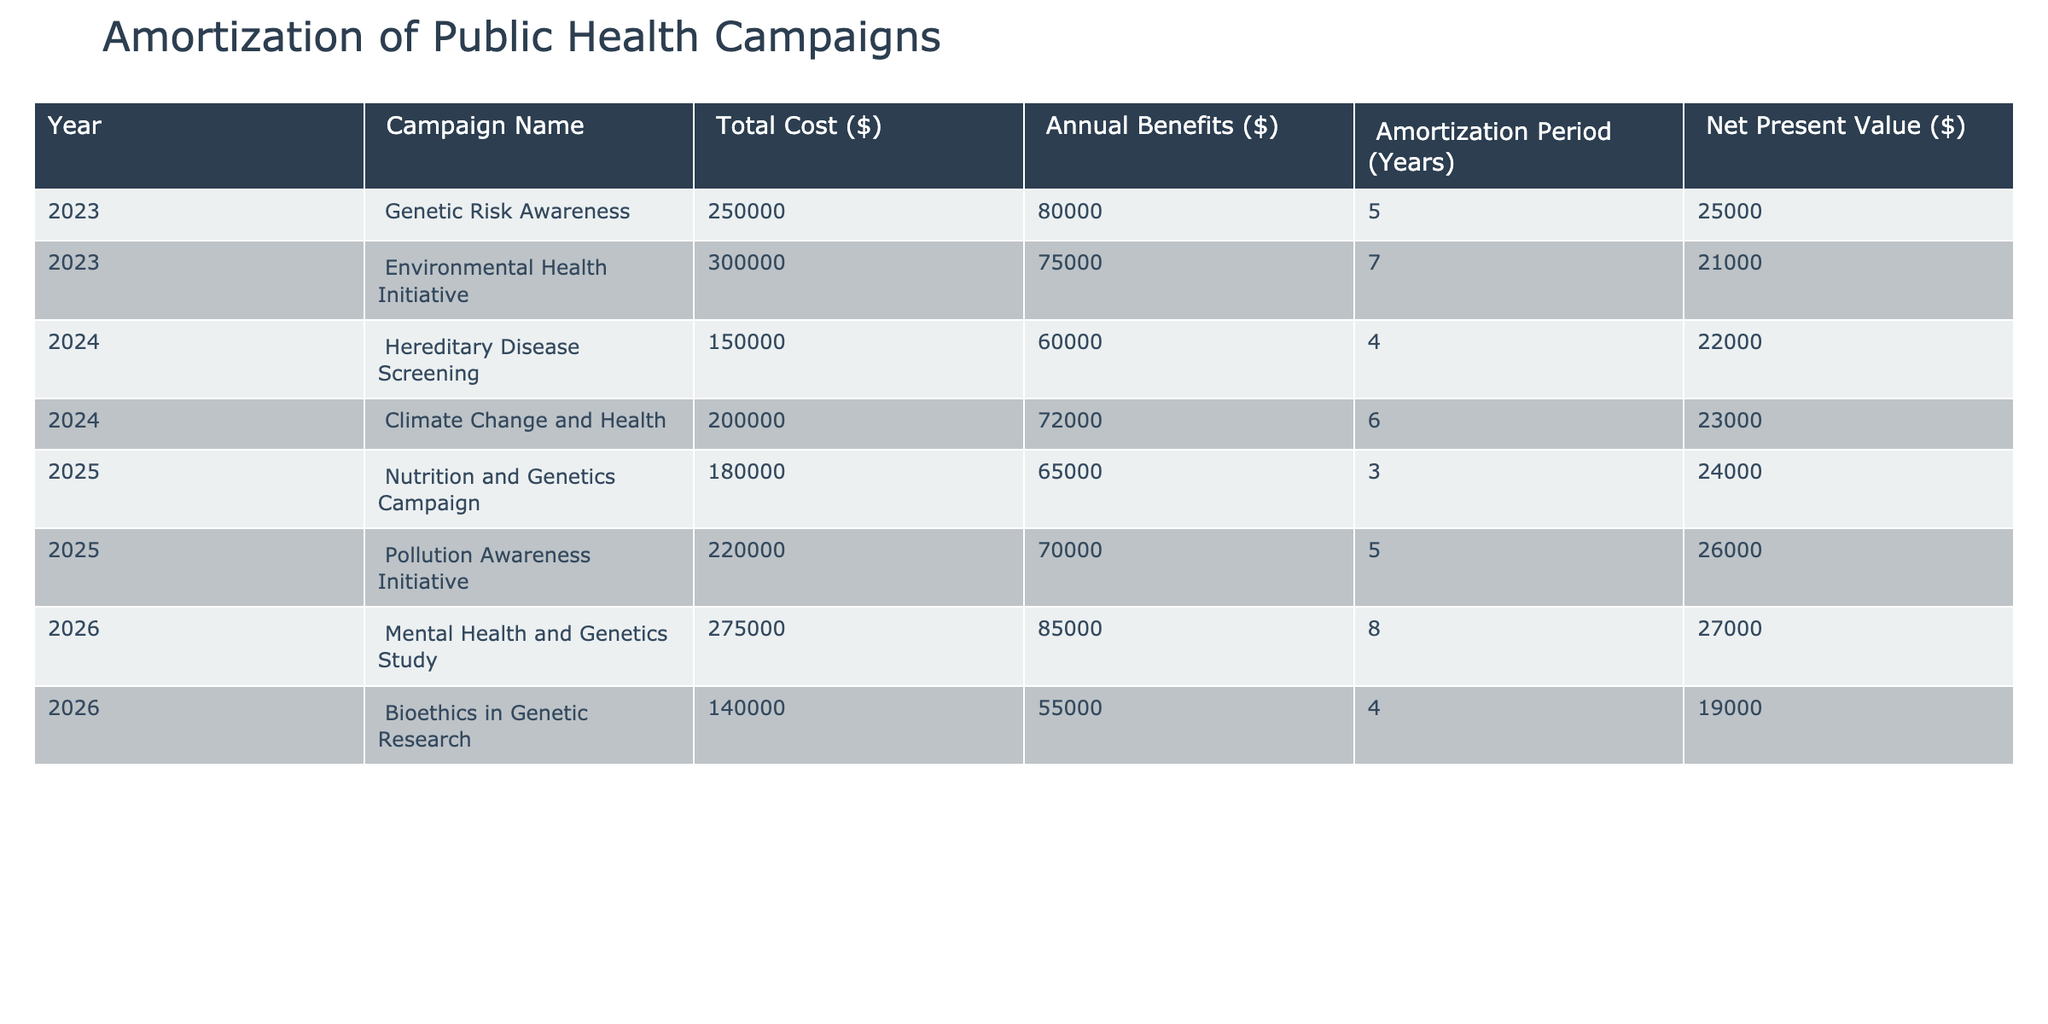What is the total cost of the Environmental Health Initiative? The table shows that the Environmental Health Initiative has a total cost of $300,000 listed in the 'Total Cost ($)' column for the year 2023.
Answer: 300000 Which campaign has the highest annual benefits? Looking at the 'Annual Benefits ($)' column, we see the Mental Health and Genetics Study has the highest benefits at $85,000 in the year 2026.
Answer: 85000 How many campaigns have an amortization period of 5 years? By examining the 'Amortization Period (Years)' column, I find that there are three campaigns that have an amortization period of 5 years: the Genetic Risk Awareness, Pollution Awareness Initiative, and one more in 2026.
Answer: 3 What is the total net present value of all campaigns listed? To find the total net present value, I add up the values listed in the 'Net Present Value ($)' column: 25000 + 21000 + 22000 + 23000 + 24000 + 26000 + 27000 + 19000 = 188000.
Answer: 188000 Is the total cost of the Hereditary Disease Screening less than the average total cost of all campaigns? First, calculate the average total cost. Adding all campaign costs: 250000 + 300000 + 150000 + 200000 + 180000 + 220000 + 275000 + 140000 = 1712500. Dividing by 8 (total campaigns) gives 214062.5. Since the cost of the Hereditary Disease Screening is $150,000, which is less than the average, the answer is yes.
Answer: Yes Which year has the campaign with the lowest total cost, and what is the campaign's name? In comparing all the total costs, the Hereditary Disease Screening in 2024 has the lowest total cost of $150,000.
Answer: 2024, Hereditary Disease Screening What is the difference between the annual benefits of the Nutrition and Genetics Campaign and the Environmental Health Initiative? The annual benefits for the Nutrition and Genetics Campaign are $65,000, while for the Environmental Health Initiative, they are $75,000. The difference is $75,000 - $65,000 = $10,000.
Answer: 10000 Are there any campaigns that have a net present value higher than $25,000? Looking at the 'Net Present Value ($)' column, the Mental Health and Genetics Study, Pollution Awareness Initiative, and others have values greater than $25,000. Hence, the statement is true.
Answer: Yes 